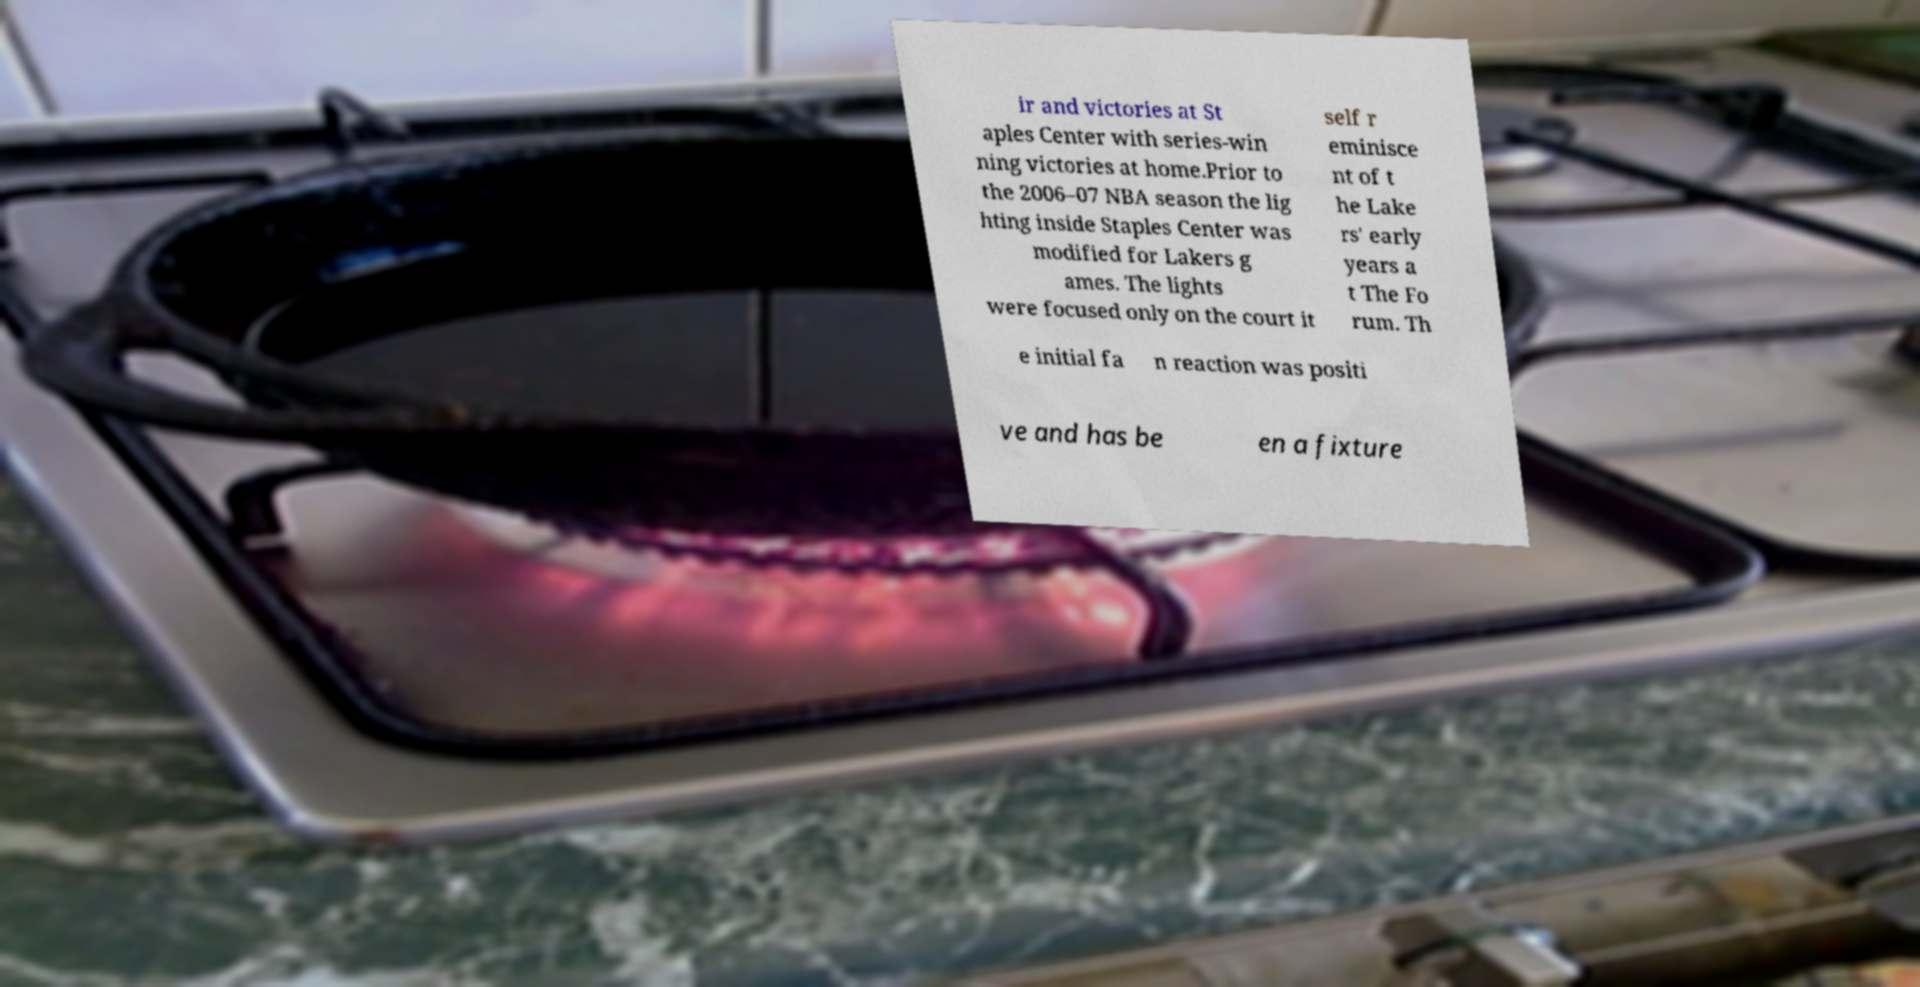Can you accurately transcribe the text from the provided image for me? ir and victories at St aples Center with series-win ning victories at home.Prior to the 2006–07 NBA season the lig hting inside Staples Center was modified for Lakers g ames. The lights were focused only on the court it self r eminisce nt of t he Lake rs' early years a t The Fo rum. Th e initial fa n reaction was positi ve and has be en a fixture 